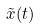Convert formula to latex. <formula><loc_0><loc_0><loc_500><loc_500>\tilde { x } ( t )</formula> 